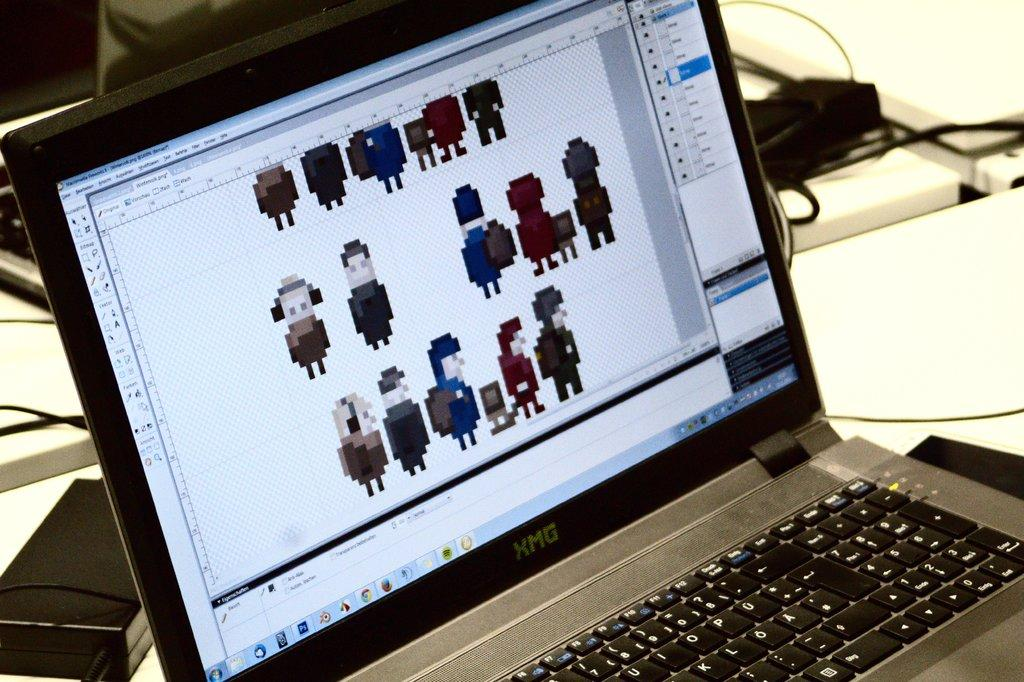<image>
Render a clear and concise summary of the photo. An open laptop has the label XMG on it. 